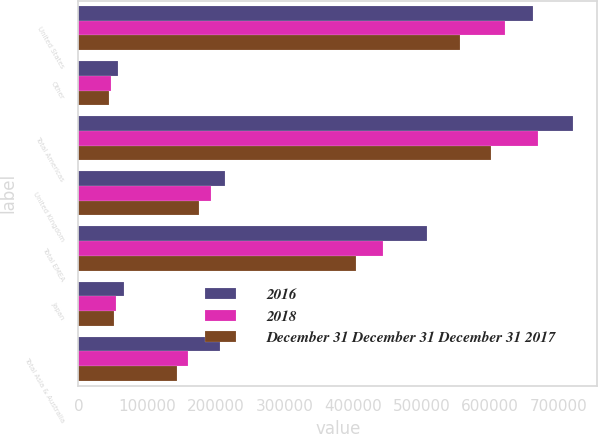<chart> <loc_0><loc_0><loc_500><loc_500><stacked_bar_chart><ecel><fcel>United States<fcel>Other<fcel>Total Americas<fcel>United Kingdom<fcel>Total EMEA<fcel>Japan<fcel>Total Asia & Australia<nl><fcel>2016<fcel>662345<fcel>58065<fcel>720410<fcel>214204<fcel>507456<fcel>67100<fcel>206118<nl><fcel>2018<fcel>622132<fcel>48139<fcel>670271<fcel>193831<fcel>444098<fcel>54351<fcel>159803<nl><fcel>December 31 December 31 December 31 2017<fcel>556777<fcel>45185<fcel>601962<fcel>175749<fcel>404759<fcel>52161<fcel>143948<nl></chart> 